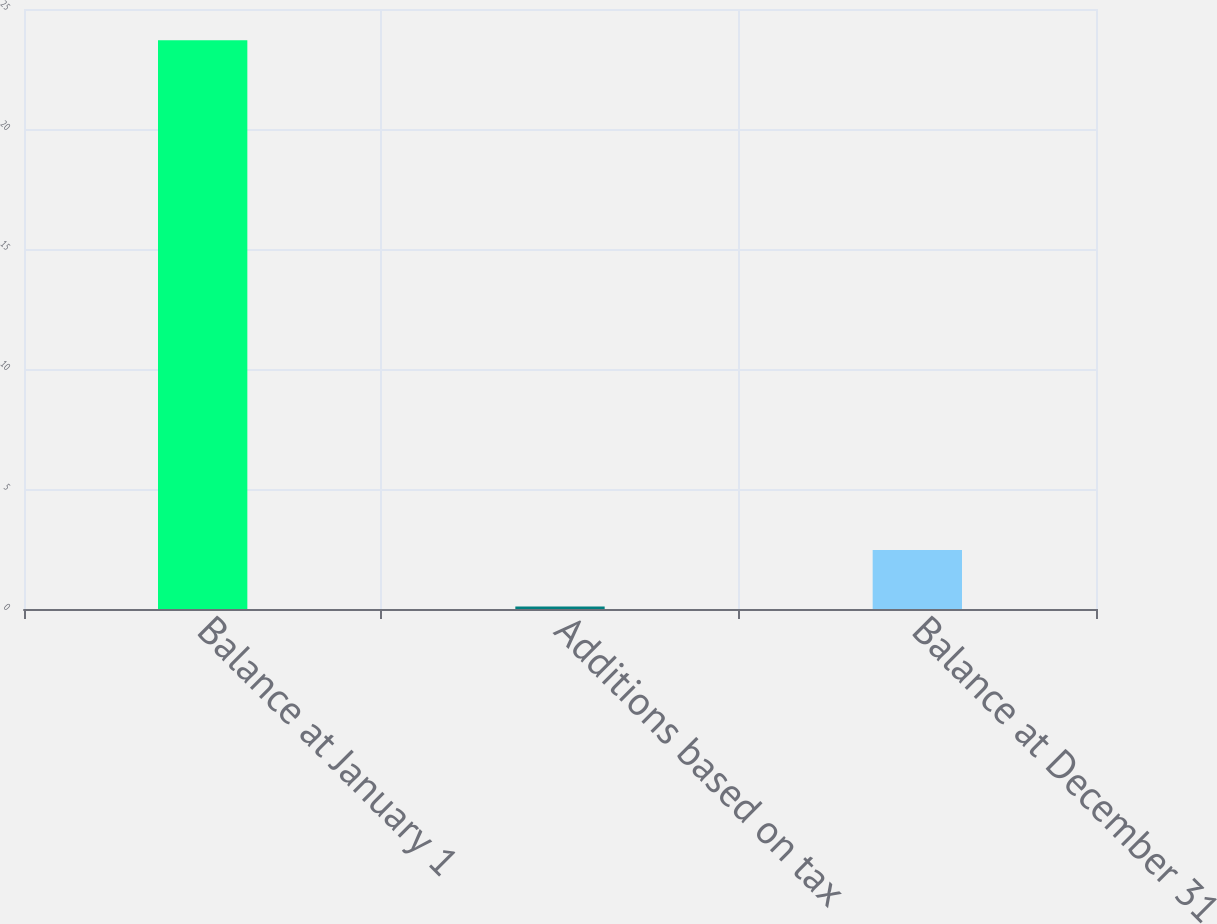<chart> <loc_0><loc_0><loc_500><loc_500><bar_chart><fcel>Balance at January 1<fcel>Additions based on tax<fcel>Balance at December 31<nl><fcel>23.7<fcel>0.1<fcel>2.46<nl></chart> 